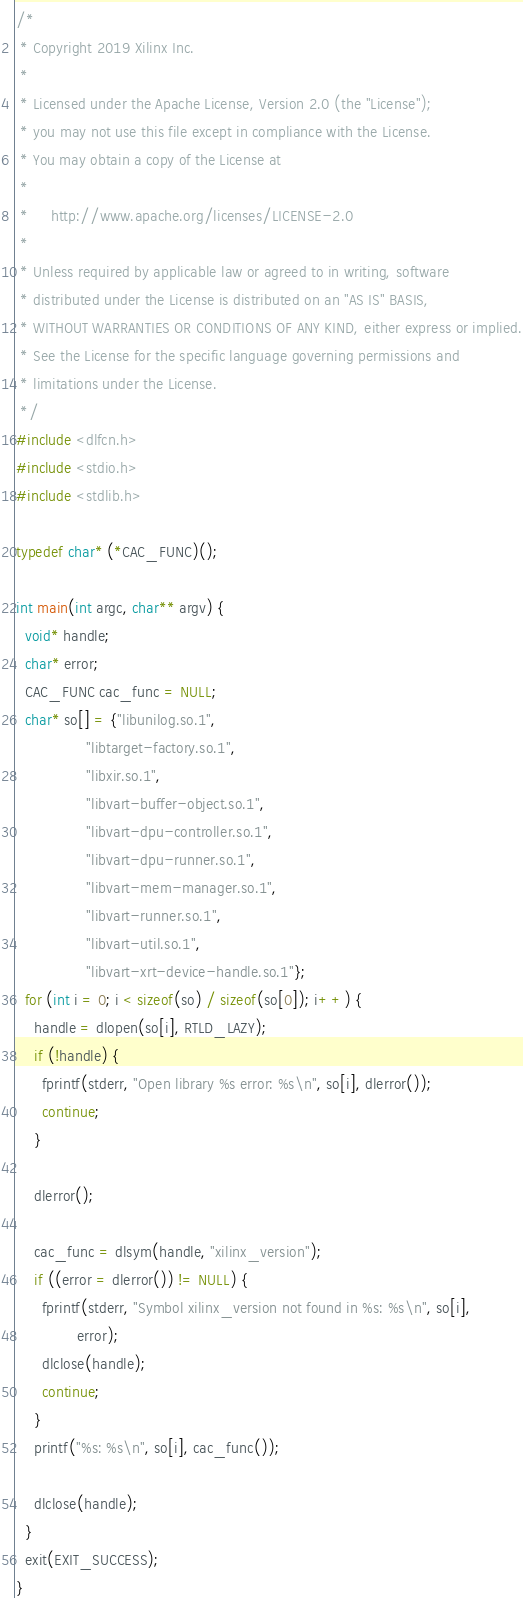<code> <loc_0><loc_0><loc_500><loc_500><_C_>/*
 * Copyright 2019 Xilinx Inc.
 *
 * Licensed under the Apache License, Version 2.0 (the "License");
 * you may not use this file except in compliance with the License.
 * You may obtain a copy of the License at
 *
 *     http://www.apache.org/licenses/LICENSE-2.0
 *
 * Unless required by applicable law or agreed to in writing, software
 * distributed under the License is distributed on an "AS IS" BASIS,
 * WITHOUT WARRANTIES OR CONDITIONS OF ANY KIND, either express or implied.
 * See the License for the specific language governing permissions and
 * limitations under the License.
 */
#include <dlfcn.h>
#include <stdio.h>
#include <stdlib.h>

typedef char* (*CAC_FUNC)();

int main(int argc, char** argv) {
  void* handle;
  char* error;
  CAC_FUNC cac_func = NULL;
  char* so[] = {"libunilog.so.1",
                "libtarget-factory.so.1",
                "libxir.so.1",
                "libvart-buffer-object.so.1",
                "libvart-dpu-controller.so.1",
                "libvart-dpu-runner.so.1",
                "libvart-mem-manager.so.1",
                "libvart-runner.so.1",
                "libvart-util.so.1",
                "libvart-xrt-device-handle.so.1"};
  for (int i = 0; i < sizeof(so) / sizeof(so[0]); i++) {
    handle = dlopen(so[i], RTLD_LAZY);
    if (!handle) {
      fprintf(stderr, "Open library %s error: %s\n", so[i], dlerror());
      continue;
    }

    dlerror();

    cac_func = dlsym(handle, "xilinx_version");
    if ((error = dlerror()) != NULL) {
      fprintf(stderr, "Symbol xilinx_version not found in %s: %s\n", so[i],
              error);
      dlclose(handle);
      continue;
    }
    printf("%s: %s\n", so[i], cac_func());

    dlclose(handle);
  }
  exit(EXIT_SUCCESS);
}
</code> 